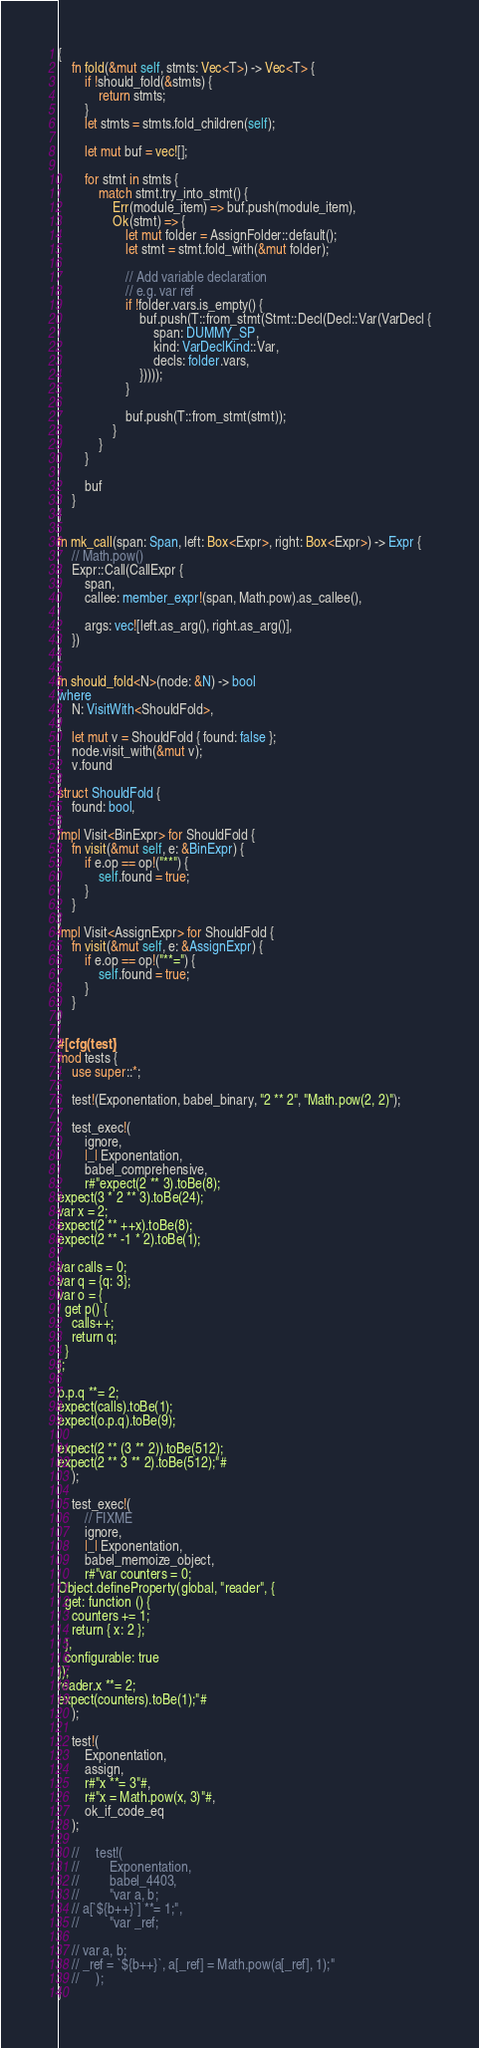Convert code to text. <code><loc_0><loc_0><loc_500><loc_500><_Rust_>{
    fn fold(&mut self, stmts: Vec<T>) -> Vec<T> {
        if !should_fold(&stmts) {
            return stmts;
        }
        let stmts = stmts.fold_children(self);

        let mut buf = vec![];

        for stmt in stmts {
            match stmt.try_into_stmt() {
                Err(module_item) => buf.push(module_item),
                Ok(stmt) => {
                    let mut folder = AssignFolder::default();
                    let stmt = stmt.fold_with(&mut folder);

                    // Add variable declaration
                    // e.g. var ref
                    if !folder.vars.is_empty() {
                        buf.push(T::from_stmt(Stmt::Decl(Decl::Var(VarDecl {
                            span: DUMMY_SP,
                            kind: VarDeclKind::Var,
                            decls: folder.vars,
                        }))));
                    }

                    buf.push(T::from_stmt(stmt));
                }
            }
        }

        buf
    }
}

fn mk_call(span: Span, left: Box<Expr>, right: Box<Expr>) -> Expr {
    // Math.pow()
    Expr::Call(CallExpr {
        span,
        callee: member_expr!(span, Math.pow).as_callee(),

        args: vec![left.as_arg(), right.as_arg()],
    })
}

fn should_fold<N>(node: &N) -> bool
where
    N: VisitWith<ShouldFold>,
{
    let mut v = ShouldFold { found: false };
    node.visit_with(&mut v);
    v.found
}
struct ShouldFold {
    found: bool,
}
impl Visit<BinExpr> for ShouldFold {
    fn visit(&mut self, e: &BinExpr) {
        if e.op == op!("**") {
            self.found = true;
        }
    }
}
impl Visit<AssignExpr> for ShouldFold {
    fn visit(&mut self, e: &AssignExpr) {
        if e.op == op!("**=") {
            self.found = true;
        }
    }
}

#[cfg(test)]
mod tests {
    use super::*;

    test!(Exponentation, babel_binary, "2 ** 2", "Math.pow(2, 2)");

    test_exec!(
        ignore,
        |_| Exponentation,
        babel_comprehensive,
        r#"expect(2 ** 3).toBe(8);
expect(3 * 2 ** 3).toBe(24);
var x = 2;
expect(2 ** ++x).toBe(8);
expect(2 ** -1 * 2).toBe(1);

var calls = 0;
var q = {q: 3};
var o = {
  get p() {
    calls++;
    return q;
  }
};

o.p.q **= 2;
expect(calls).toBe(1);
expect(o.p.q).toBe(9);

expect(2 ** (3 ** 2)).toBe(512);
expect(2 ** 3 ** 2).toBe(512);"#
    );

    test_exec!(
        // FIXME
        ignore,
        |_| Exponentation,
        babel_memoize_object,
        r#"var counters = 0;
Object.defineProperty(global, "reader", {
  get: function () {
    counters += 1;
    return { x: 2 };
  },
  configurable: true
});
reader.x **= 2;
expect(counters).toBe(1);"#
    );

    test!(
        Exponentation,
        assign,
        r#"x **= 3"#,
        r#"x = Math.pow(x, 3)"#,
        ok_if_code_eq
    );

    //     test!(
    //         Exponentation,
    //         babel_4403,
    //         "var a, b;
    // a[`${b++}`] **= 1;",
    //         "var _ref;

    // var a, b;
    // _ref = `${b++}`, a[_ref] = Math.pow(a[_ref], 1);"
    //     );
}
</code> 